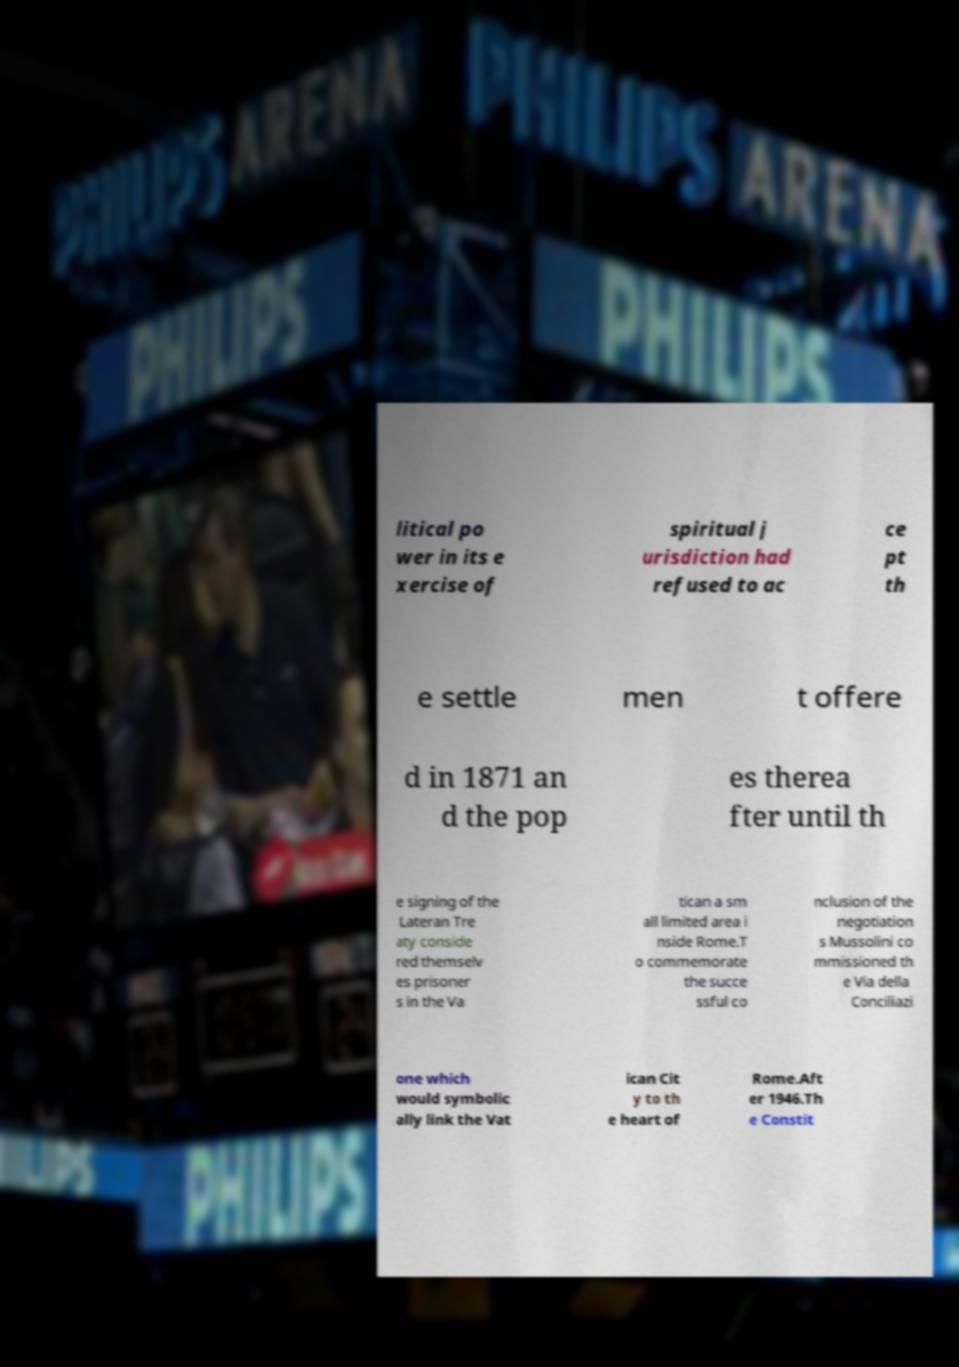Can you accurately transcribe the text from the provided image for me? litical po wer in its e xercise of spiritual j urisdiction had refused to ac ce pt th e settle men t offere d in 1871 an d the pop es therea fter until th e signing of the Lateran Tre aty conside red themselv es prisoner s in the Va tican a sm all limited area i nside Rome.T o commemorate the succe ssful co nclusion of the negotiation s Mussolini co mmissioned th e Via della Conciliazi one which would symbolic ally link the Vat ican Cit y to th e heart of Rome.Aft er 1946.Th e Constit 